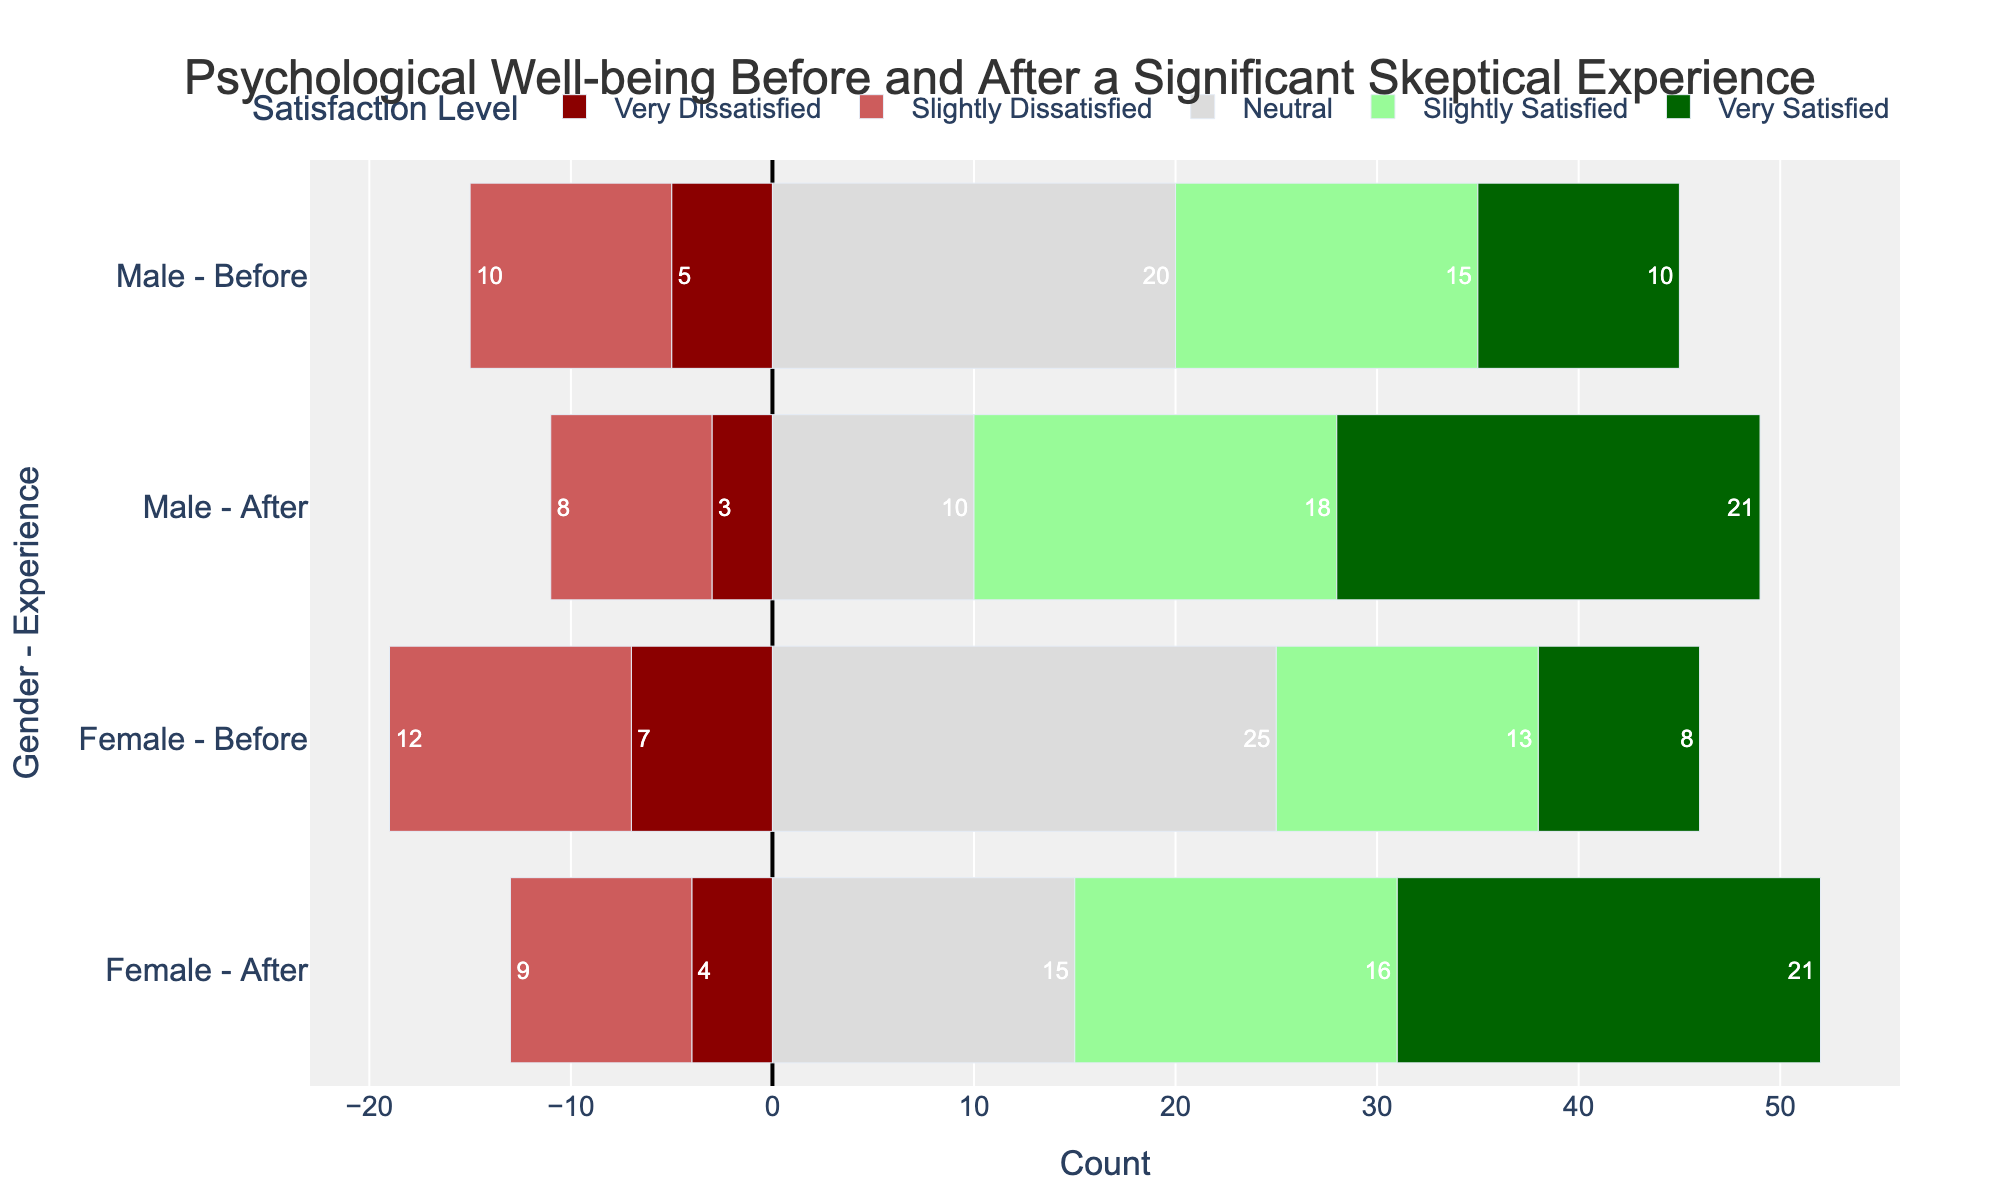Which gender and experience combination shows the highest count of "Very Satisfied" individuals? Looking at the bars in the chart, identify the "Very Satisfied" category (green color) and find the longest bar among all four gender and experience combinations.
Answer: Female - After How does the count of "Very Dissatisfied" individuals before the experience compare between males and females? Compare the lengths of the red bars in the "Before" condition for both genders. Calculate the difference between the counts for males and females.
Answer: Females have 2 more than males What is the combined total count of "Neutral" responses for males and females after the experience? Look at the "Neutral" category (grey color) for the "After" experience in both genders. Sum the counts for males and females.
Answer: 25 Which group saw the largest increase in the count of "Very Satisfied" individuals after the experience? Compare the increases in the count of "Very Satisfied" individuals from the "Before" to "After" experiences for both genders. Identify the group with the largest increase.
Answer: Female What is the total count of dissatisfied individuals (both Very and Slightly Dissatisfied) for males after the experience? Add the counts of "Very Dissatisfied" and "Slightly Dissatisfied" individuals for males in the "After" experience condition.
Answer: 11 Who has a higher count of "Slightly Satisfied" individuals after the experience: males or females? Compare the lengths of the dark green bars representing "Slightly Satisfied" in the "After" condition between males and females.
Answer: Male Which gender had a greater reduction in the count of "Very Dissatisfied" individuals after the experience? Calculate the reduction in the count of "Very Dissatisfied" individuals from before to after the experience for both genders and compare them.
Answer: Male What is the difference between the counts of "Slightly Dissatisfied" individuals before and after the experience for females? Calculate the difference between the counts of "Slightly Dissatisfied" individuals for females in the "Before" and "After" conditions.
Answer: 3 Which category shows the greatest improvement in psychological well-being for males after the experience? Look at the changes in the bar lengths for each category from "Before" to "After" for males. Identify the category with the largest positive change.
Answer: Very Satisfied 